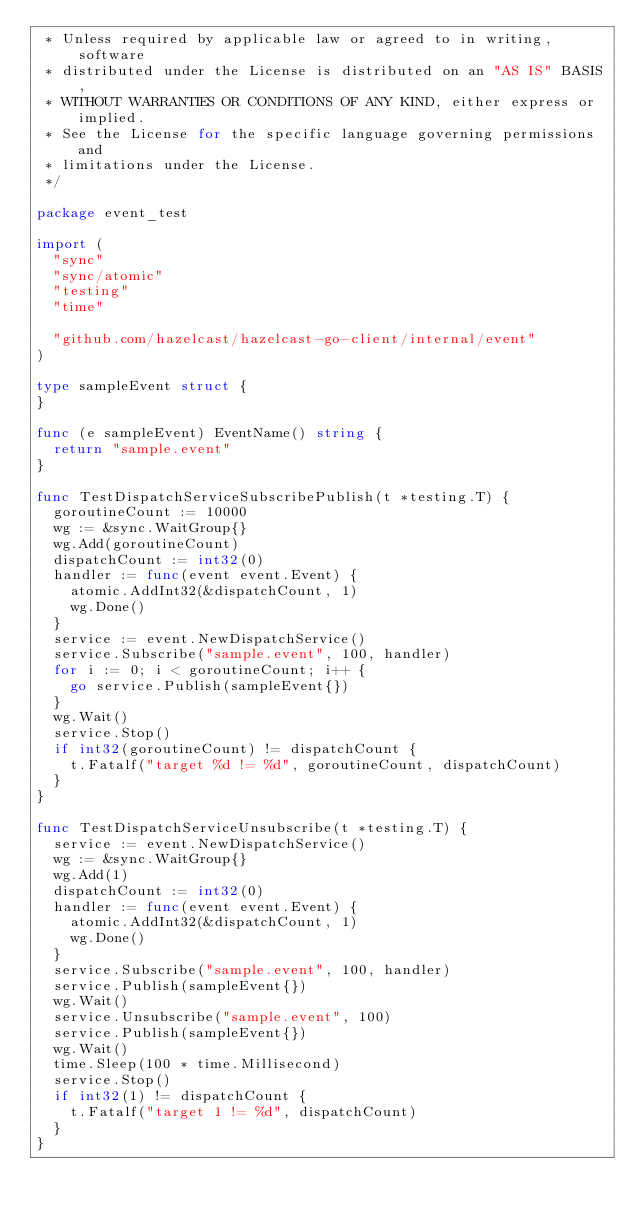Convert code to text. <code><loc_0><loc_0><loc_500><loc_500><_Go_> * Unless required by applicable law or agreed to in writing, software
 * distributed under the License is distributed on an "AS IS" BASIS,
 * WITHOUT WARRANTIES OR CONDITIONS OF ANY KIND, either express or implied.
 * See the License for the specific language governing permissions and
 * limitations under the License.
 */

package event_test

import (
	"sync"
	"sync/atomic"
	"testing"
	"time"

	"github.com/hazelcast/hazelcast-go-client/internal/event"
)

type sampleEvent struct {
}

func (e sampleEvent) EventName() string {
	return "sample.event"
}

func TestDispatchServiceSubscribePublish(t *testing.T) {
	goroutineCount := 10000
	wg := &sync.WaitGroup{}
	wg.Add(goroutineCount)
	dispatchCount := int32(0)
	handler := func(event event.Event) {
		atomic.AddInt32(&dispatchCount, 1)
		wg.Done()
	}
	service := event.NewDispatchService()
	service.Subscribe("sample.event", 100, handler)
	for i := 0; i < goroutineCount; i++ {
		go service.Publish(sampleEvent{})
	}
	wg.Wait()
	service.Stop()
	if int32(goroutineCount) != dispatchCount {
		t.Fatalf("target %d != %d", goroutineCount, dispatchCount)
	}
}

func TestDispatchServiceUnsubscribe(t *testing.T) {
	service := event.NewDispatchService()
	wg := &sync.WaitGroup{}
	wg.Add(1)
	dispatchCount := int32(0)
	handler := func(event event.Event) {
		atomic.AddInt32(&dispatchCount, 1)
		wg.Done()
	}
	service.Subscribe("sample.event", 100, handler)
	service.Publish(sampleEvent{})
	wg.Wait()
	service.Unsubscribe("sample.event", 100)
	service.Publish(sampleEvent{})
	wg.Wait()
	time.Sleep(100 * time.Millisecond)
	service.Stop()
	if int32(1) != dispatchCount {
		t.Fatalf("target 1 != %d", dispatchCount)
	}
}
</code> 